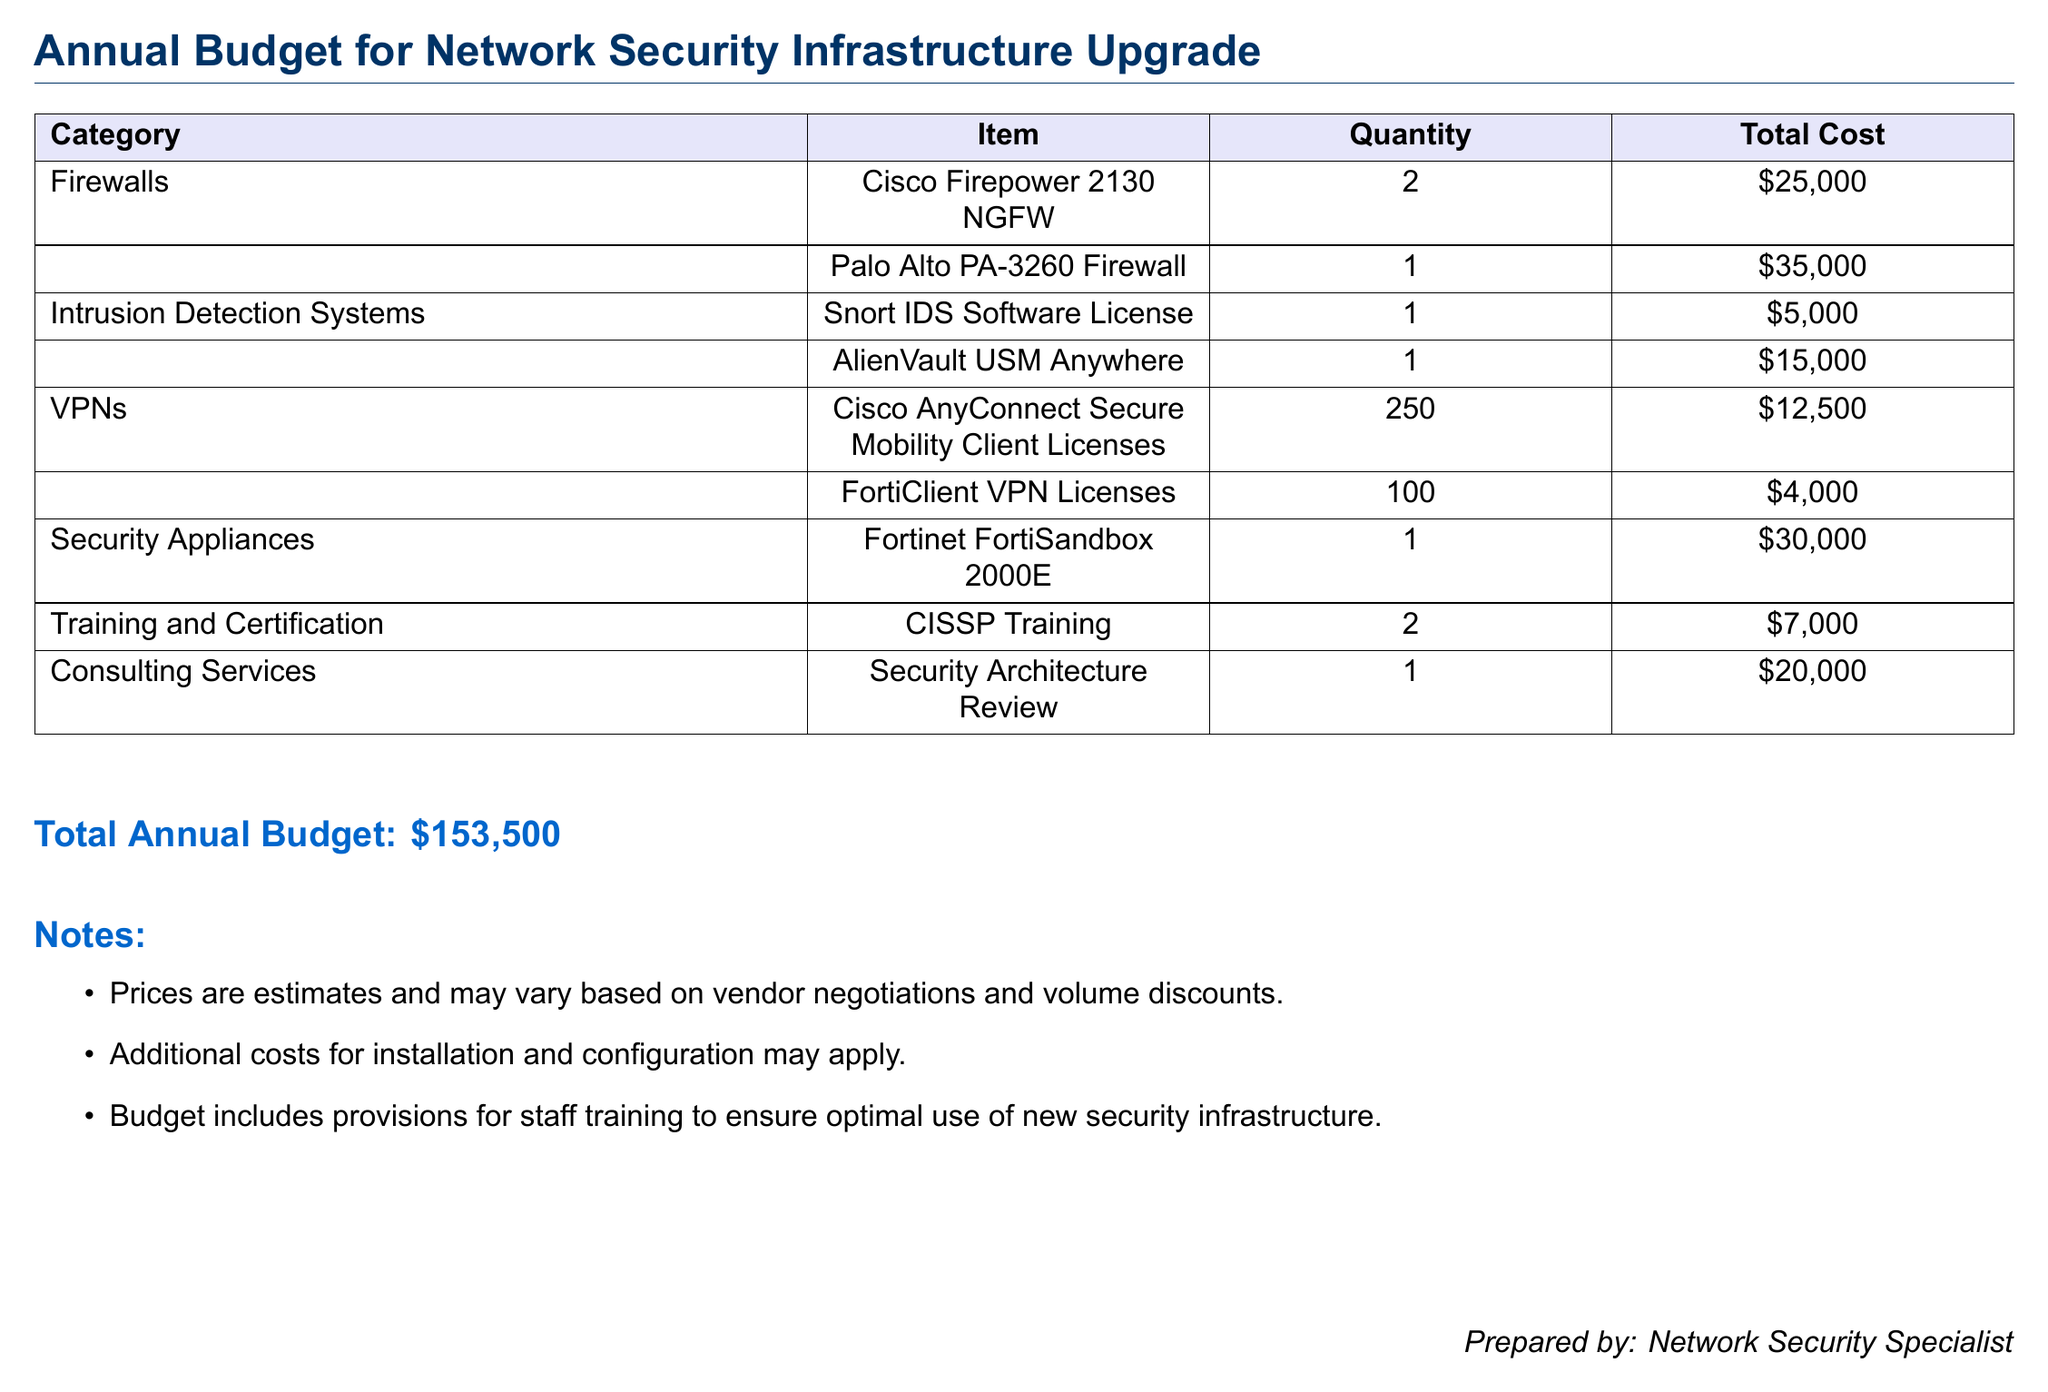What is the total annual budget? The total annual budget is summarized at the end of the document, amounting to $153,500.
Answer: $153,500 How many Cisco Firepower 2130 NGFWs are included? The document specifies that 2 units of Cisco Firepower 2130 NGFW are included under firewalls.
Answer: 2 What is the cost of the Palo Alto PA-3260 Firewall? The document lists the cost of the Palo Alto PA-3260 Firewall as $35,000.
Answer: $35,000 How many licenses of FortiClient VPN are proposed? The budget details state that 100 licenses of FortiClient VPN are proposed.
Answer: 100 What is the cost for CISSP Training? The document states that the total cost for CISSP Training is $7,000, covering 2 training sessions.
Answer: $7,000 Which consulting service is included in the budget? The budget includes a Security Architecture Review as a consulting service.
Answer: Security Architecture Review What is the total number of Cisco AnyConnect Secure Mobility Client Licenses? The total number of Cisco AnyConnect licenses listed in the document is 250.
Answer: 250 How much is allocated for the AlienVault USM Anywhere? The cost allocated for AlienVault USM Anywhere is stated as $15,000 in the document.
Answer: $15,000 Are additional costs for installation mentioned? Yes, the document notes that additional costs for installation and configuration may apply.
Answer: Yes 